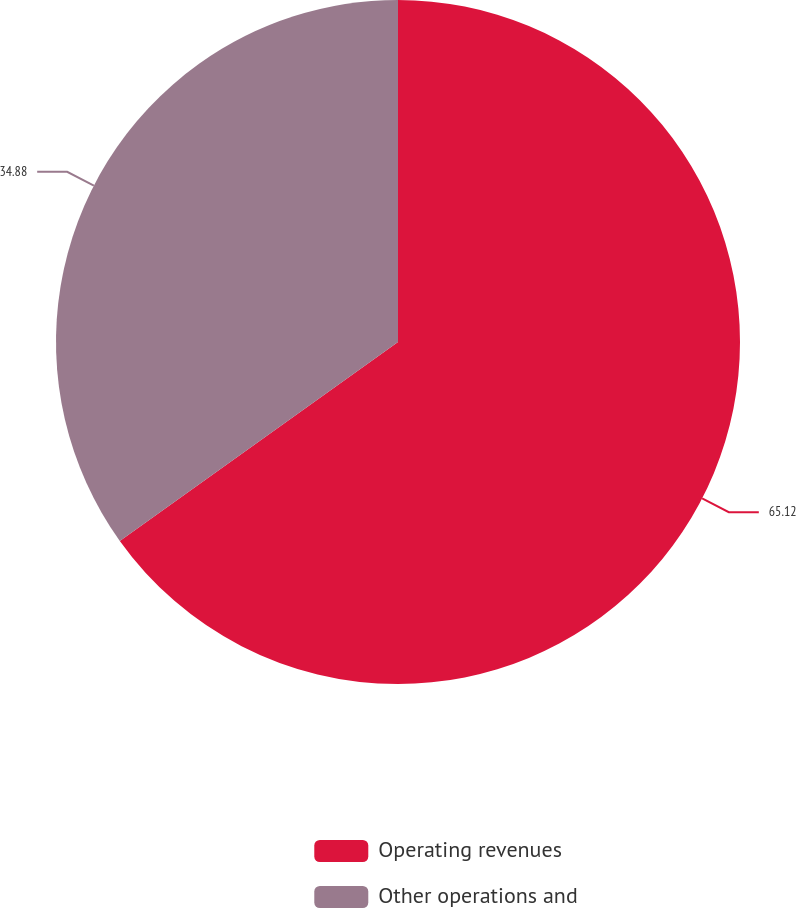Convert chart to OTSL. <chart><loc_0><loc_0><loc_500><loc_500><pie_chart><fcel>Operating revenues<fcel>Other operations and<nl><fcel>65.12%<fcel>34.88%<nl></chart> 